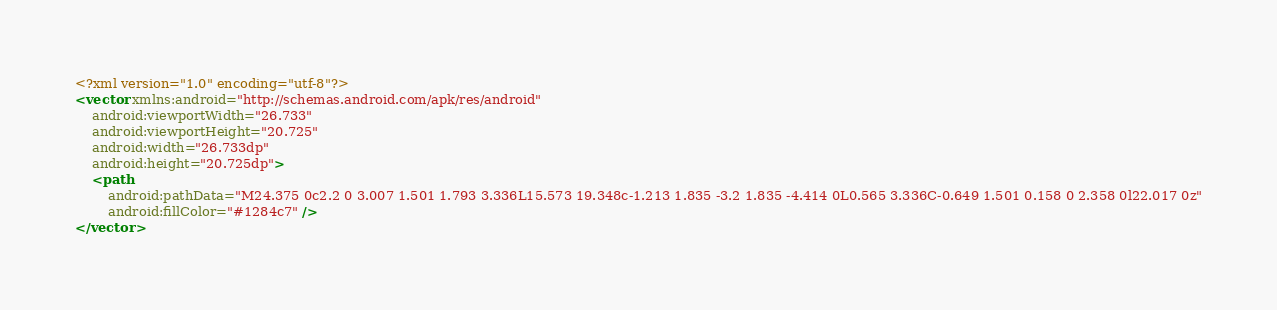<code> <loc_0><loc_0><loc_500><loc_500><_XML_><?xml version="1.0" encoding="utf-8"?>
<vector xmlns:android="http://schemas.android.com/apk/res/android"
    android:viewportWidth="26.733"
    android:viewportHeight="20.725"
    android:width="26.733dp"
    android:height="20.725dp">
    <path
        android:pathData="M24.375 0c2.2 0 3.007 1.501 1.793 3.336L15.573 19.348c-1.213 1.835 -3.2 1.835 -4.414 0L0.565 3.336C-0.649 1.501 0.158 0 2.358 0l22.017 0z"
        android:fillColor="#1284c7" />
</vector></code> 